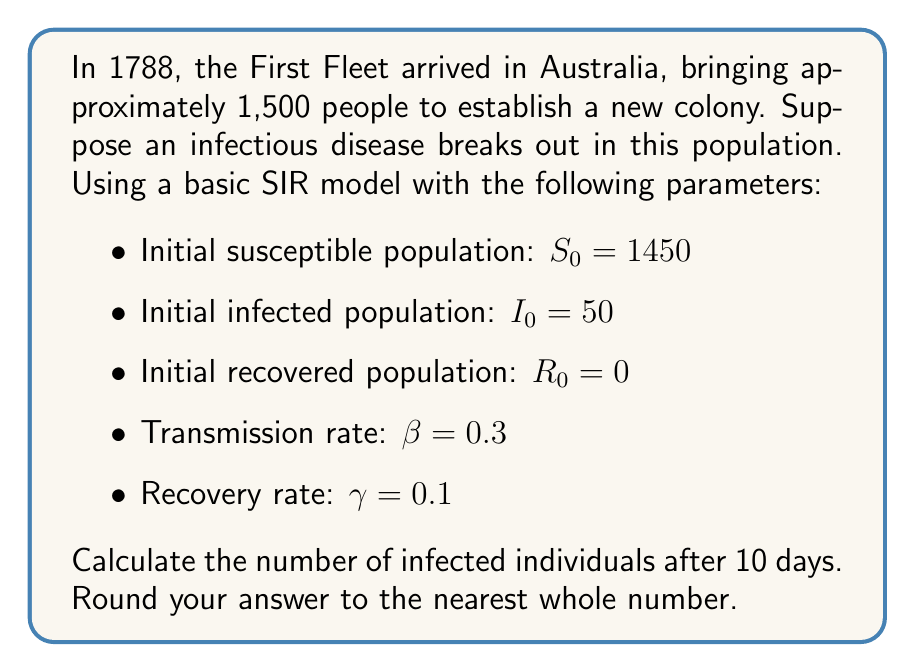Could you help me with this problem? To solve this problem, we'll use the SIR (Susceptible, Infected, Recovered) model, which is described by the following system of differential equations:

$$\begin{align}
\frac{dS}{dt} &= -\beta SI \\
\frac{dI}{dt} &= \beta SI - \gamma I \\
\frac{dR}{dt} &= \gamma I
\end{align}$$

Where:
- $S$ is the number of susceptible individuals
- $I$ is the number of infected individuals
- $R$ is the number of recovered individuals
- $\beta$ is the transmission rate
- $\gamma$ is the recovery rate

To find the number of infected individuals after 10 days, we need to solve these equations numerically. We can use the Euler method for approximation:

$$\begin{align}
S_{n+1} &= S_n - \beta S_n I_n \Delta t \\
I_{n+1} &= I_n + (\beta S_n I_n - \gamma I_n) \Delta t \\
R_{n+1} &= R_n + \gamma I_n \Delta t
\end{align}$$

Let's use a time step of $\Delta t = 0.1$ days, so we need to perform 100 iterations to reach 10 days.

Starting values:
$S_0 = 1450$
$I_0 = 50$
$R_0 = 0$

We can implement this in a programming language or spreadsheet. After 100 iterations, we get:

$S_{100} \approx 710.76$
$I_{100} \approx 534.24$
$R_{100} \approx 255.00$

The number of infected individuals after 10 days is approximately 534.24, which rounds to 534.
Answer: 534 